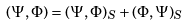Convert formula to latex. <formula><loc_0><loc_0><loc_500><loc_500>( \Psi , \Phi ) = ( \Psi , \Phi ) _ { S } + ( \Phi , \Psi ) _ { S }</formula> 